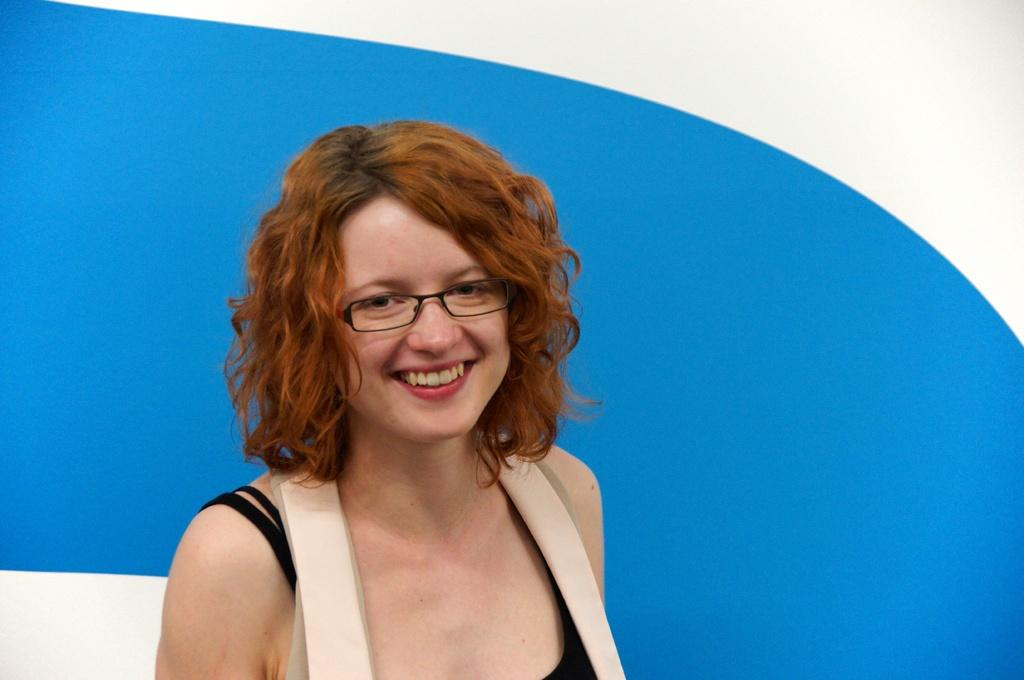Who is the main subject in the image? There is a lady in the image. What is the lady wearing in the image? The lady is wearing glasses (specs) in the image. What is the lady's facial expression in the image? The lady is smiling in the image. What can be seen in the background of the image? There is a blue and white wall in the background of the image. What type of joke is the lady telling on the hill in the image? There is no hill or joke present in the image; it features a lady wearing glasses and smiling in front of a blue and white wall. 